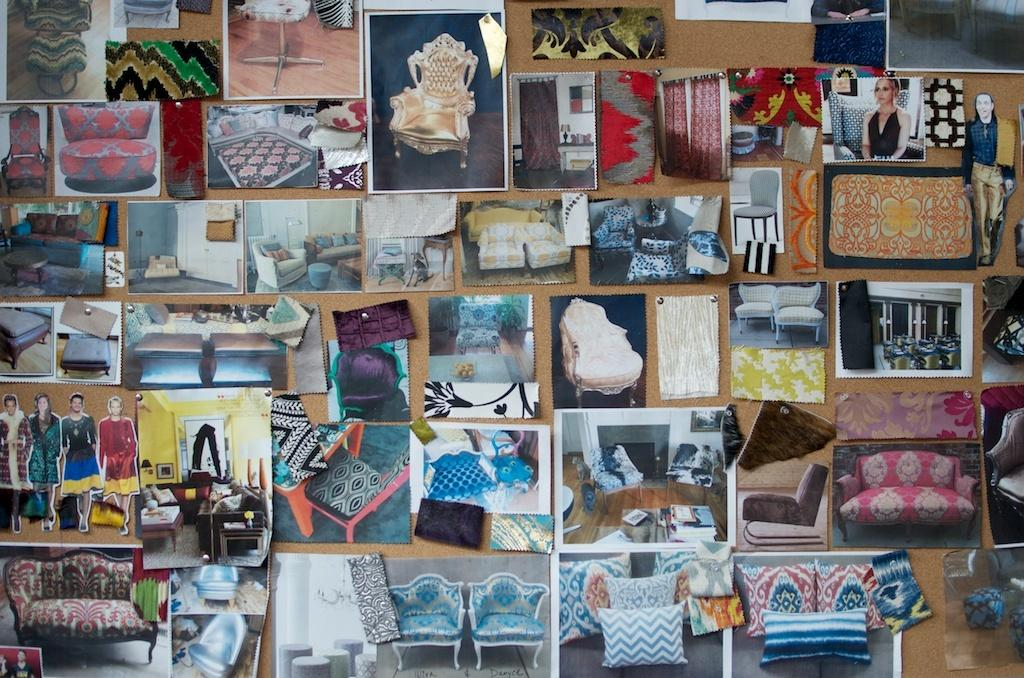What is the main object in the image? There is a notice board in the image. What is attached to the notice board? Photographs are pinned to the notice board. What type of wire can be seen connecting the land to the ocean in the image? There is no wire, land, or ocean present in the image; it only features a notice board with photographs pinned to it. 